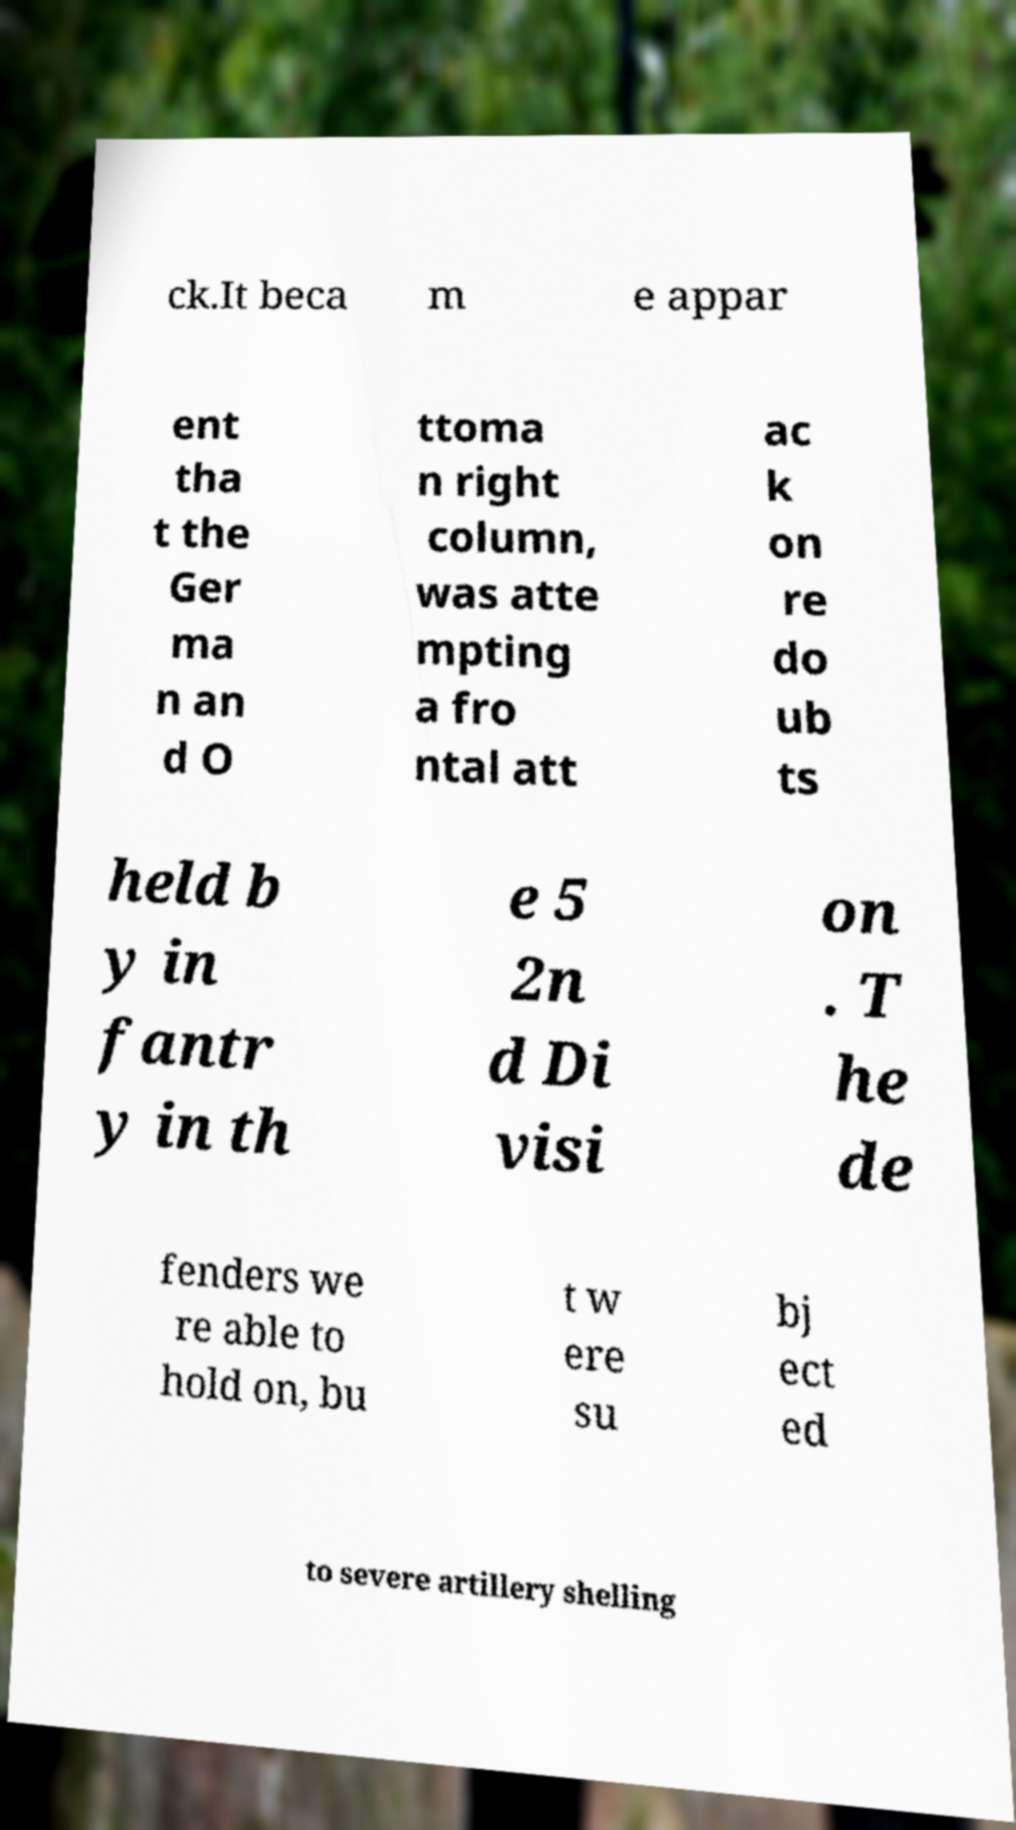I need the written content from this picture converted into text. Can you do that? ck.It beca m e appar ent tha t the Ger ma n an d O ttoma n right column, was atte mpting a fro ntal att ac k on re do ub ts held b y in fantr y in th e 5 2n d Di visi on . T he de fenders we re able to hold on, bu t w ere su bj ect ed to severe artillery shelling 